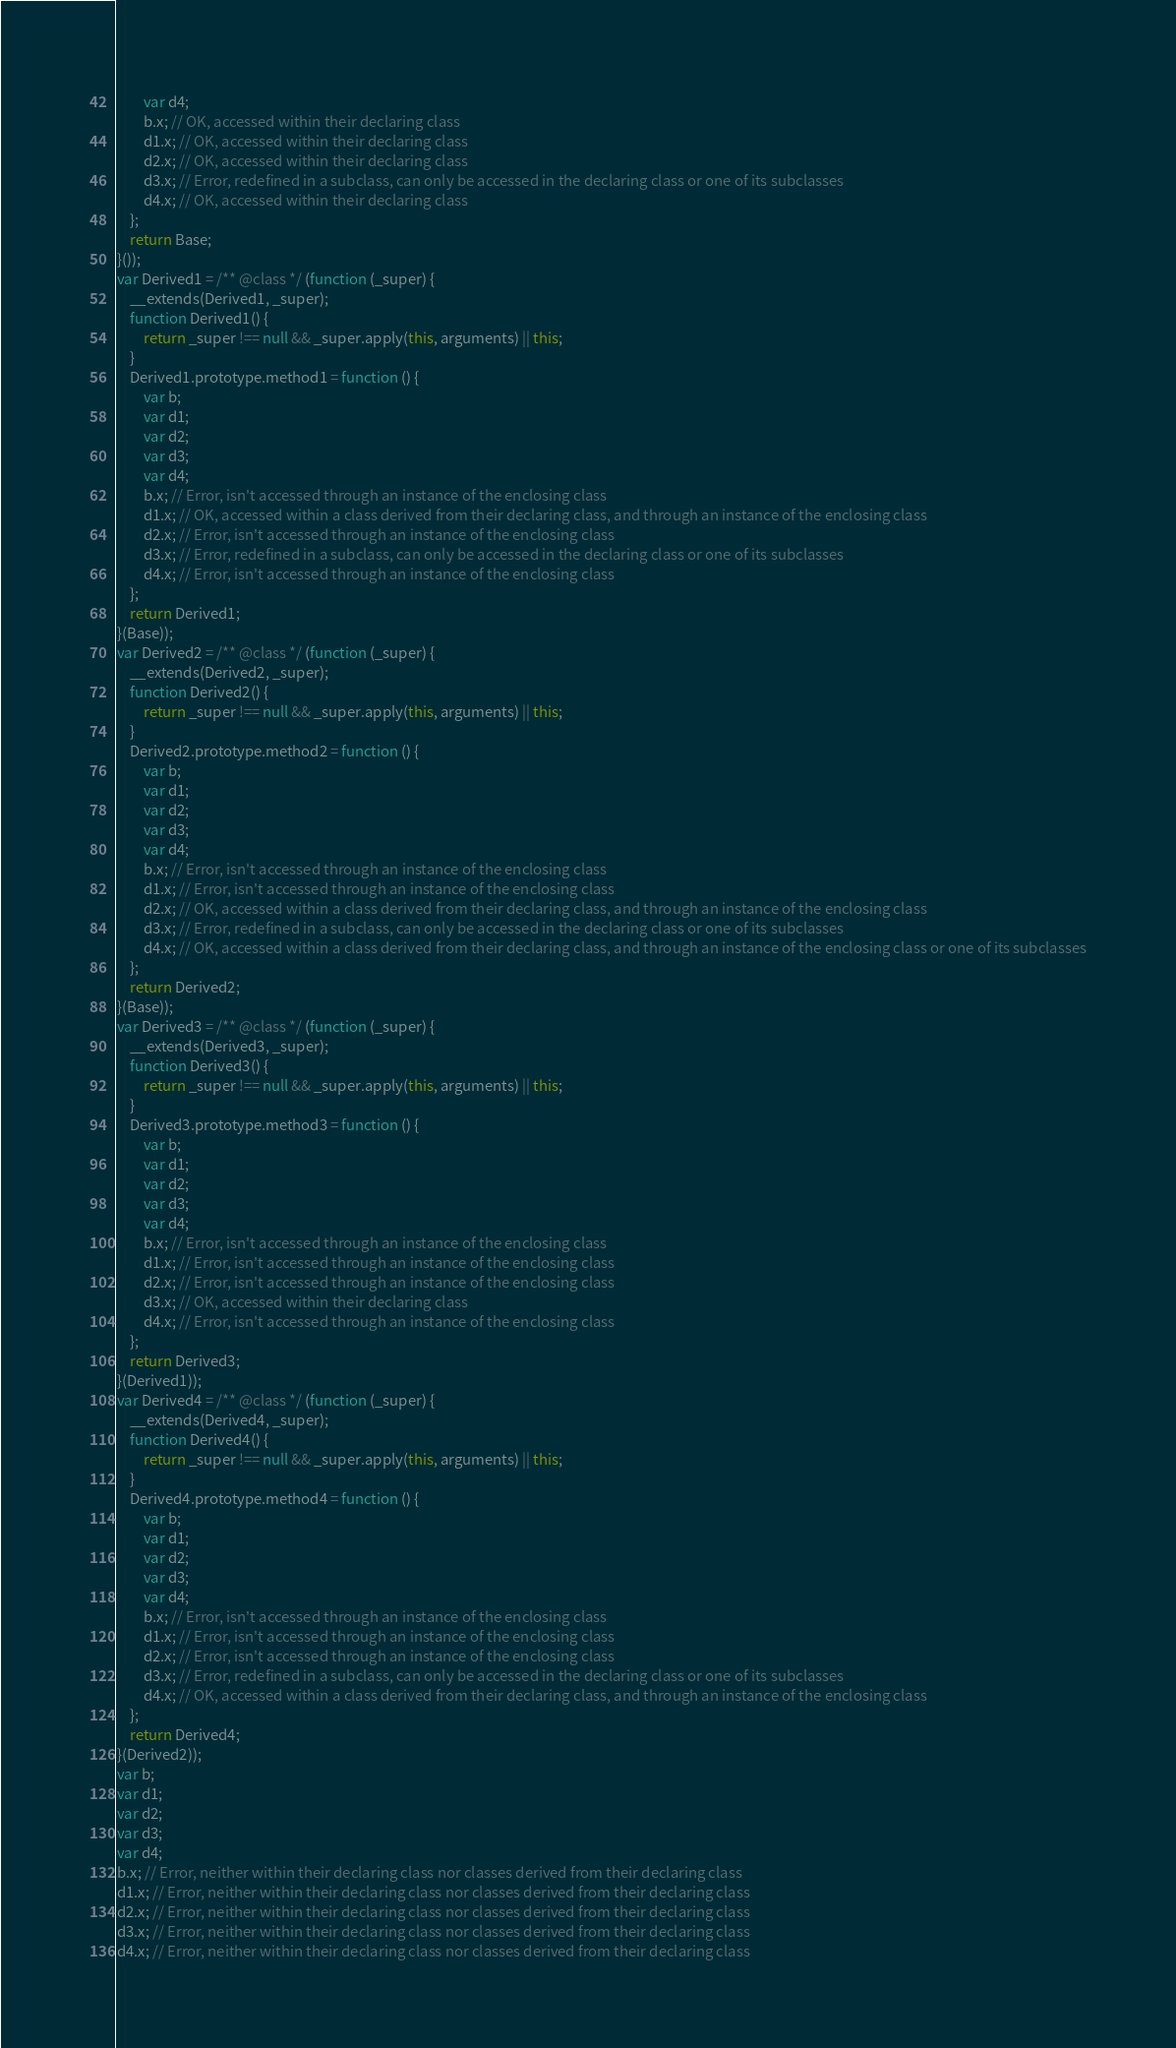Convert code to text. <code><loc_0><loc_0><loc_500><loc_500><_JavaScript_>        var d4;
        b.x; // OK, accessed within their declaring class
        d1.x; // OK, accessed within their declaring class
        d2.x; // OK, accessed within their declaring class
        d3.x; // Error, redefined in a subclass, can only be accessed in the declaring class or one of its subclasses
        d4.x; // OK, accessed within their declaring class
    };
    return Base;
}());
var Derived1 = /** @class */ (function (_super) {
    __extends(Derived1, _super);
    function Derived1() {
        return _super !== null && _super.apply(this, arguments) || this;
    }
    Derived1.prototype.method1 = function () {
        var b;
        var d1;
        var d2;
        var d3;
        var d4;
        b.x; // Error, isn't accessed through an instance of the enclosing class
        d1.x; // OK, accessed within a class derived from their declaring class, and through an instance of the enclosing class
        d2.x; // Error, isn't accessed through an instance of the enclosing class
        d3.x; // Error, redefined in a subclass, can only be accessed in the declaring class or one of its subclasses
        d4.x; // Error, isn't accessed through an instance of the enclosing class
    };
    return Derived1;
}(Base));
var Derived2 = /** @class */ (function (_super) {
    __extends(Derived2, _super);
    function Derived2() {
        return _super !== null && _super.apply(this, arguments) || this;
    }
    Derived2.prototype.method2 = function () {
        var b;
        var d1;
        var d2;
        var d3;
        var d4;
        b.x; // Error, isn't accessed through an instance of the enclosing class
        d1.x; // Error, isn't accessed through an instance of the enclosing class
        d2.x; // OK, accessed within a class derived from their declaring class, and through an instance of the enclosing class
        d3.x; // Error, redefined in a subclass, can only be accessed in the declaring class or one of its subclasses
        d4.x; // OK, accessed within a class derived from their declaring class, and through an instance of the enclosing class or one of its subclasses
    };
    return Derived2;
}(Base));
var Derived3 = /** @class */ (function (_super) {
    __extends(Derived3, _super);
    function Derived3() {
        return _super !== null && _super.apply(this, arguments) || this;
    }
    Derived3.prototype.method3 = function () {
        var b;
        var d1;
        var d2;
        var d3;
        var d4;
        b.x; // Error, isn't accessed through an instance of the enclosing class
        d1.x; // Error, isn't accessed through an instance of the enclosing class
        d2.x; // Error, isn't accessed through an instance of the enclosing class
        d3.x; // OK, accessed within their declaring class
        d4.x; // Error, isn't accessed through an instance of the enclosing class
    };
    return Derived3;
}(Derived1));
var Derived4 = /** @class */ (function (_super) {
    __extends(Derived4, _super);
    function Derived4() {
        return _super !== null && _super.apply(this, arguments) || this;
    }
    Derived4.prototype.method4 = function () {
        var b;
        var d1;
        var d2;
        var d3;
        var d4;
        b.x; // Error, isn't accessed through an instance of the enclosing class
        d1.x; // Error, isn't accessed through an instance of the enclosing class
        d2.x; // Error, isn't accessed through an instance of the enclosing class
        d3.x; // Error, redefined in a subclass, can only be accessed in the declaring class or one of its subclasses
        d4.x; // OK, accessed within a class derived from their declaring class, and through an instance of the enclosing class
    };
    return Derived4;
}(Derived2));
var b;
var d1;
var d2;
var d3;
var d4;
b.x; // Error, neither within their declaring class nor classes derived from their declaring class
d1.x; // Error, neither within their declaring class nor classes derived from their declaring class
d2.x; // Error, neither within their declaring class nor classes derived from their declaring class
d3.x; // Error, neither within their declaring class nor classes derived from their declaring class
d4.x; // Error, neither within their declaring class nor classes derived from their declaring class
</code> 